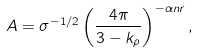<formula> <loc_0><loc_0><loc_500><loc_500>A = \sigma ^ { - 1 / 2 } \left ( \frac { 4 \pi } { 3 - k _ { \rho } } \right ) ^ { - \alpha n r } ,</formula> 